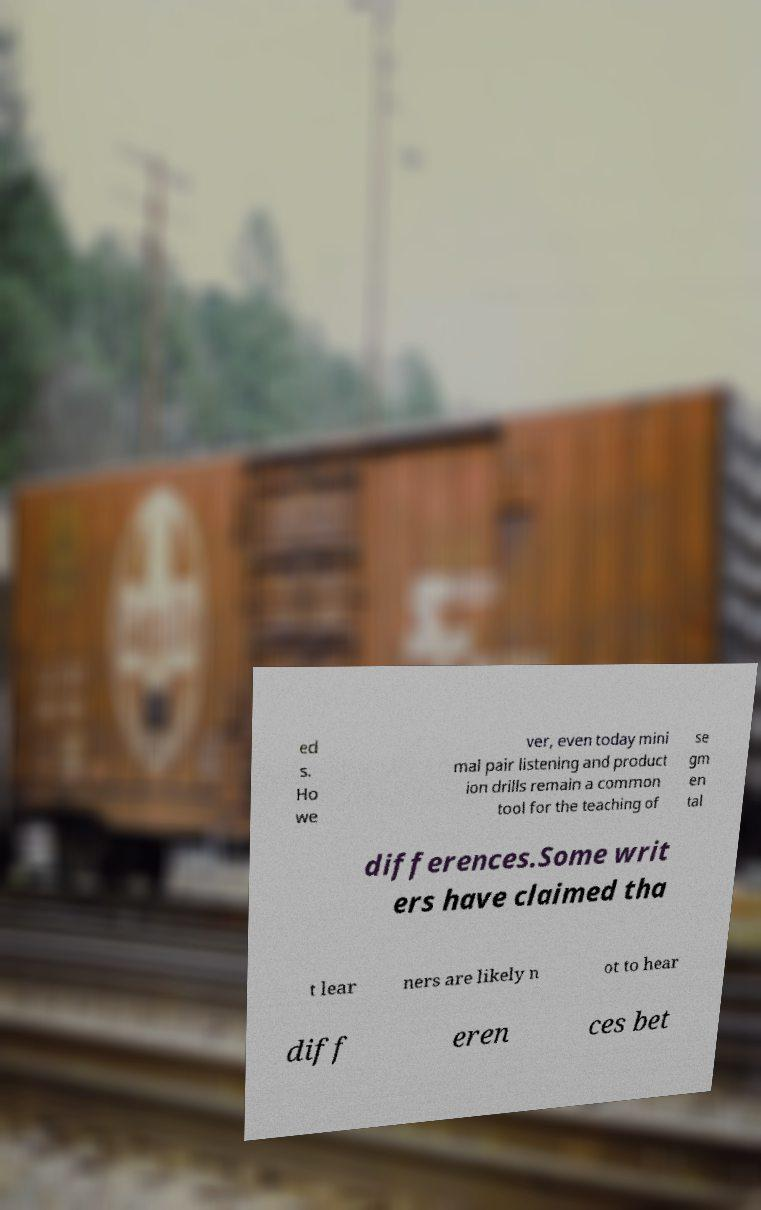Can you accurately transcribe the text from the provided image for me? ed s. Ho we ver, even today mini mal pair listening and product ion drills remain a common tool for the teaching of se gm en tal differences.Some writ ers have claimed tha t lear ners are likely n ot to hear diff eren ces bet 